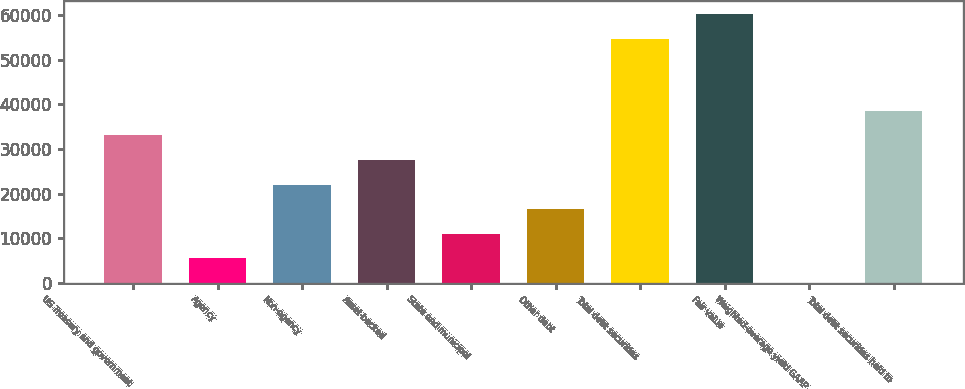Convert chart. <chart><loc_0><loc_0><loc_500><loc_500><bar_chart><fcel>US Treasury and government<fcel>Agency<fcel>Non-agency<fcel>Asset-backed<fcel>State and municipal<fcel>Other debt<fcel>Total debt securities<fcel>Fair value<fcel>Weighted-average yield GAAP<fcel>Total debt securities held to<nl><fcel>33103.7<fcel>5519.56<fcel>22070<fcel>27586.9<fcel>11036.4<fcel>16553.2<fcel>54679<fcel>60195.8<fcel>2.73<fcel>38620.5<nl></chart> 